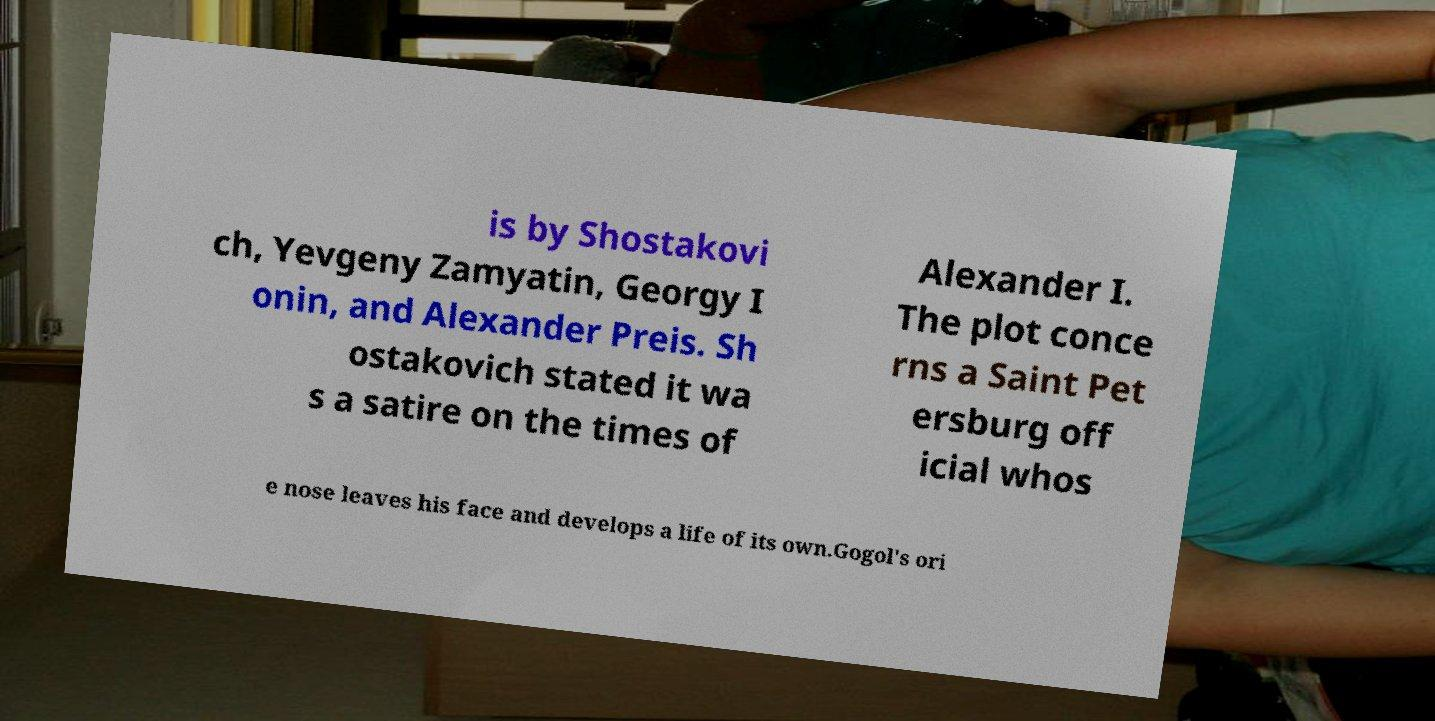What messages or text are displayed in this image? I need them in a readable, typed format. is by Shostakovi ch, Yevgeny Zamyatin, Georgy I onin, and Alexander Preis. Sh ostakovich stated it wa s a satire on the times of Alexander I. The plot conce rns a Saint Pet ersburg off icial whos e nose leaves his face and develops a life of its own.Gogol's ori 